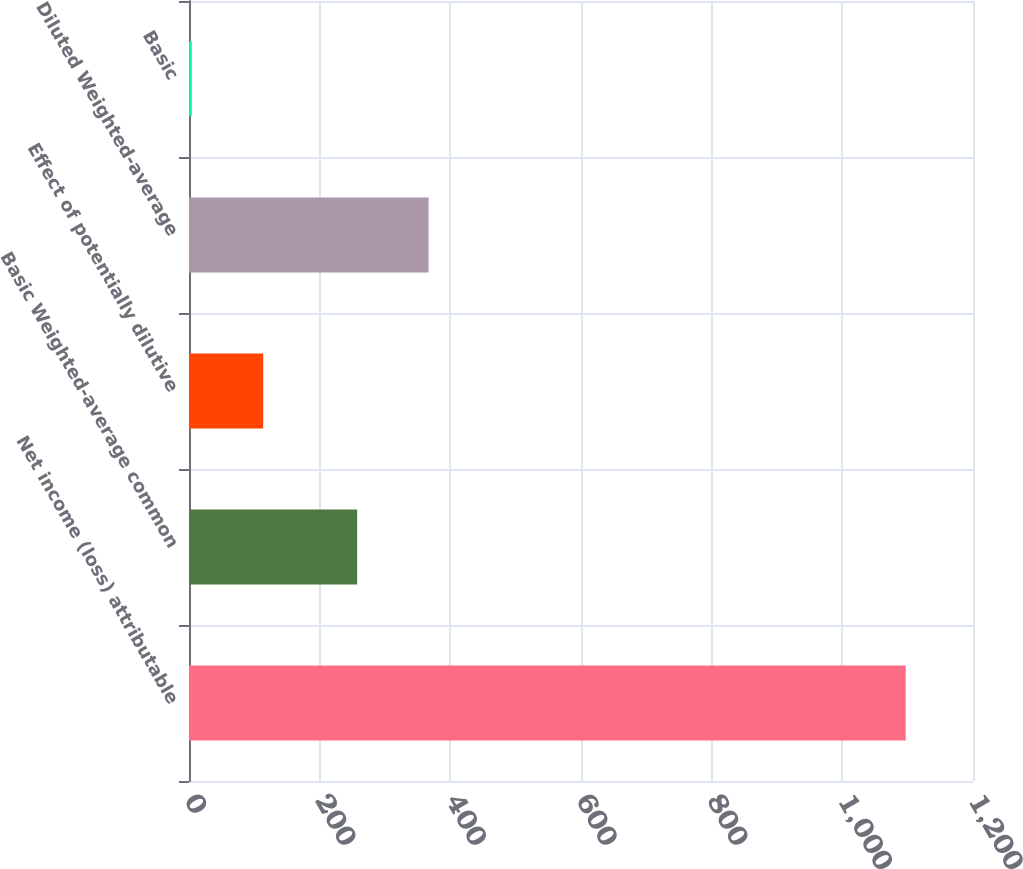<chart> <loc_0><loc_0><loc_500><loc_500><bar_chart><fcel>Net income (loss) attributable<fcel>Basic Weighted-average common<fcel>Effect of potentially dilutive<fcel>Diluted Weighted-average<fcel>Basic<nl><fcel>1097<fcel>257.4<fcel>113.53<fcel>366.67<fcel>4.26<nl></chart> 